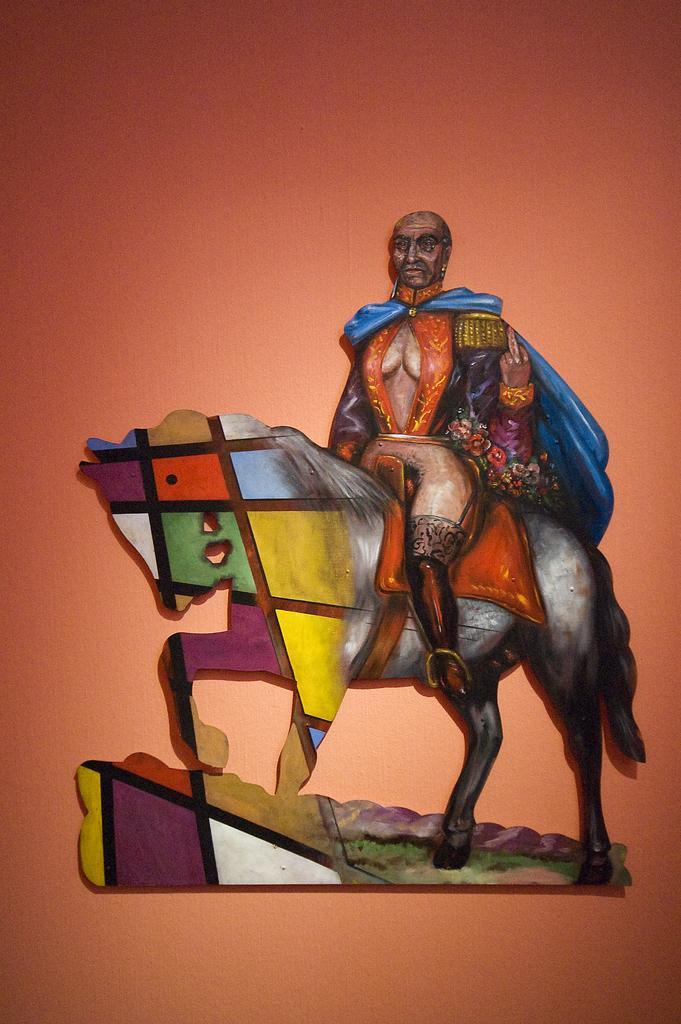Describe this image in one or two sentences. In this picture we can see a board of a person sitting on a horse and this board is on the surface. 